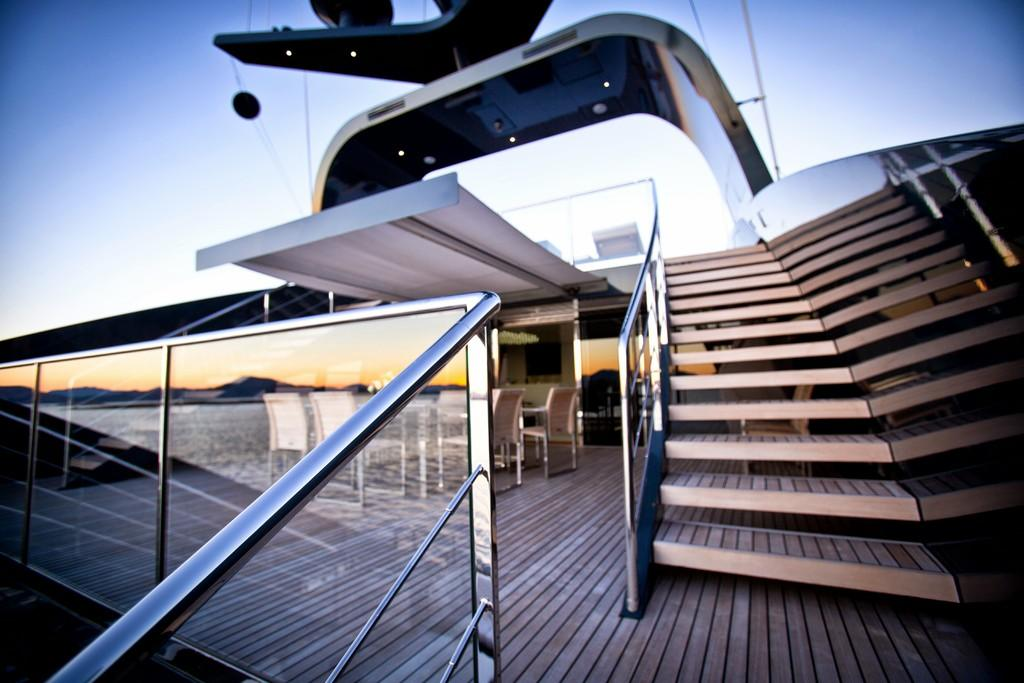What type of building is shown in the image? There is a glass building in the image. What can be seen on the right side of the image? There are steps on the right side of the image. What furniture is present on the left side of the image? There are chairs around a table on the left side of the image. What kind of barrier is visible on the left side bottom of the image? There is a glass fence on the left side bottom of the image. What type of bulb is used to light up the chairs in the image? There are no bulbs present in the image; the chairs are not lit up in the image. 